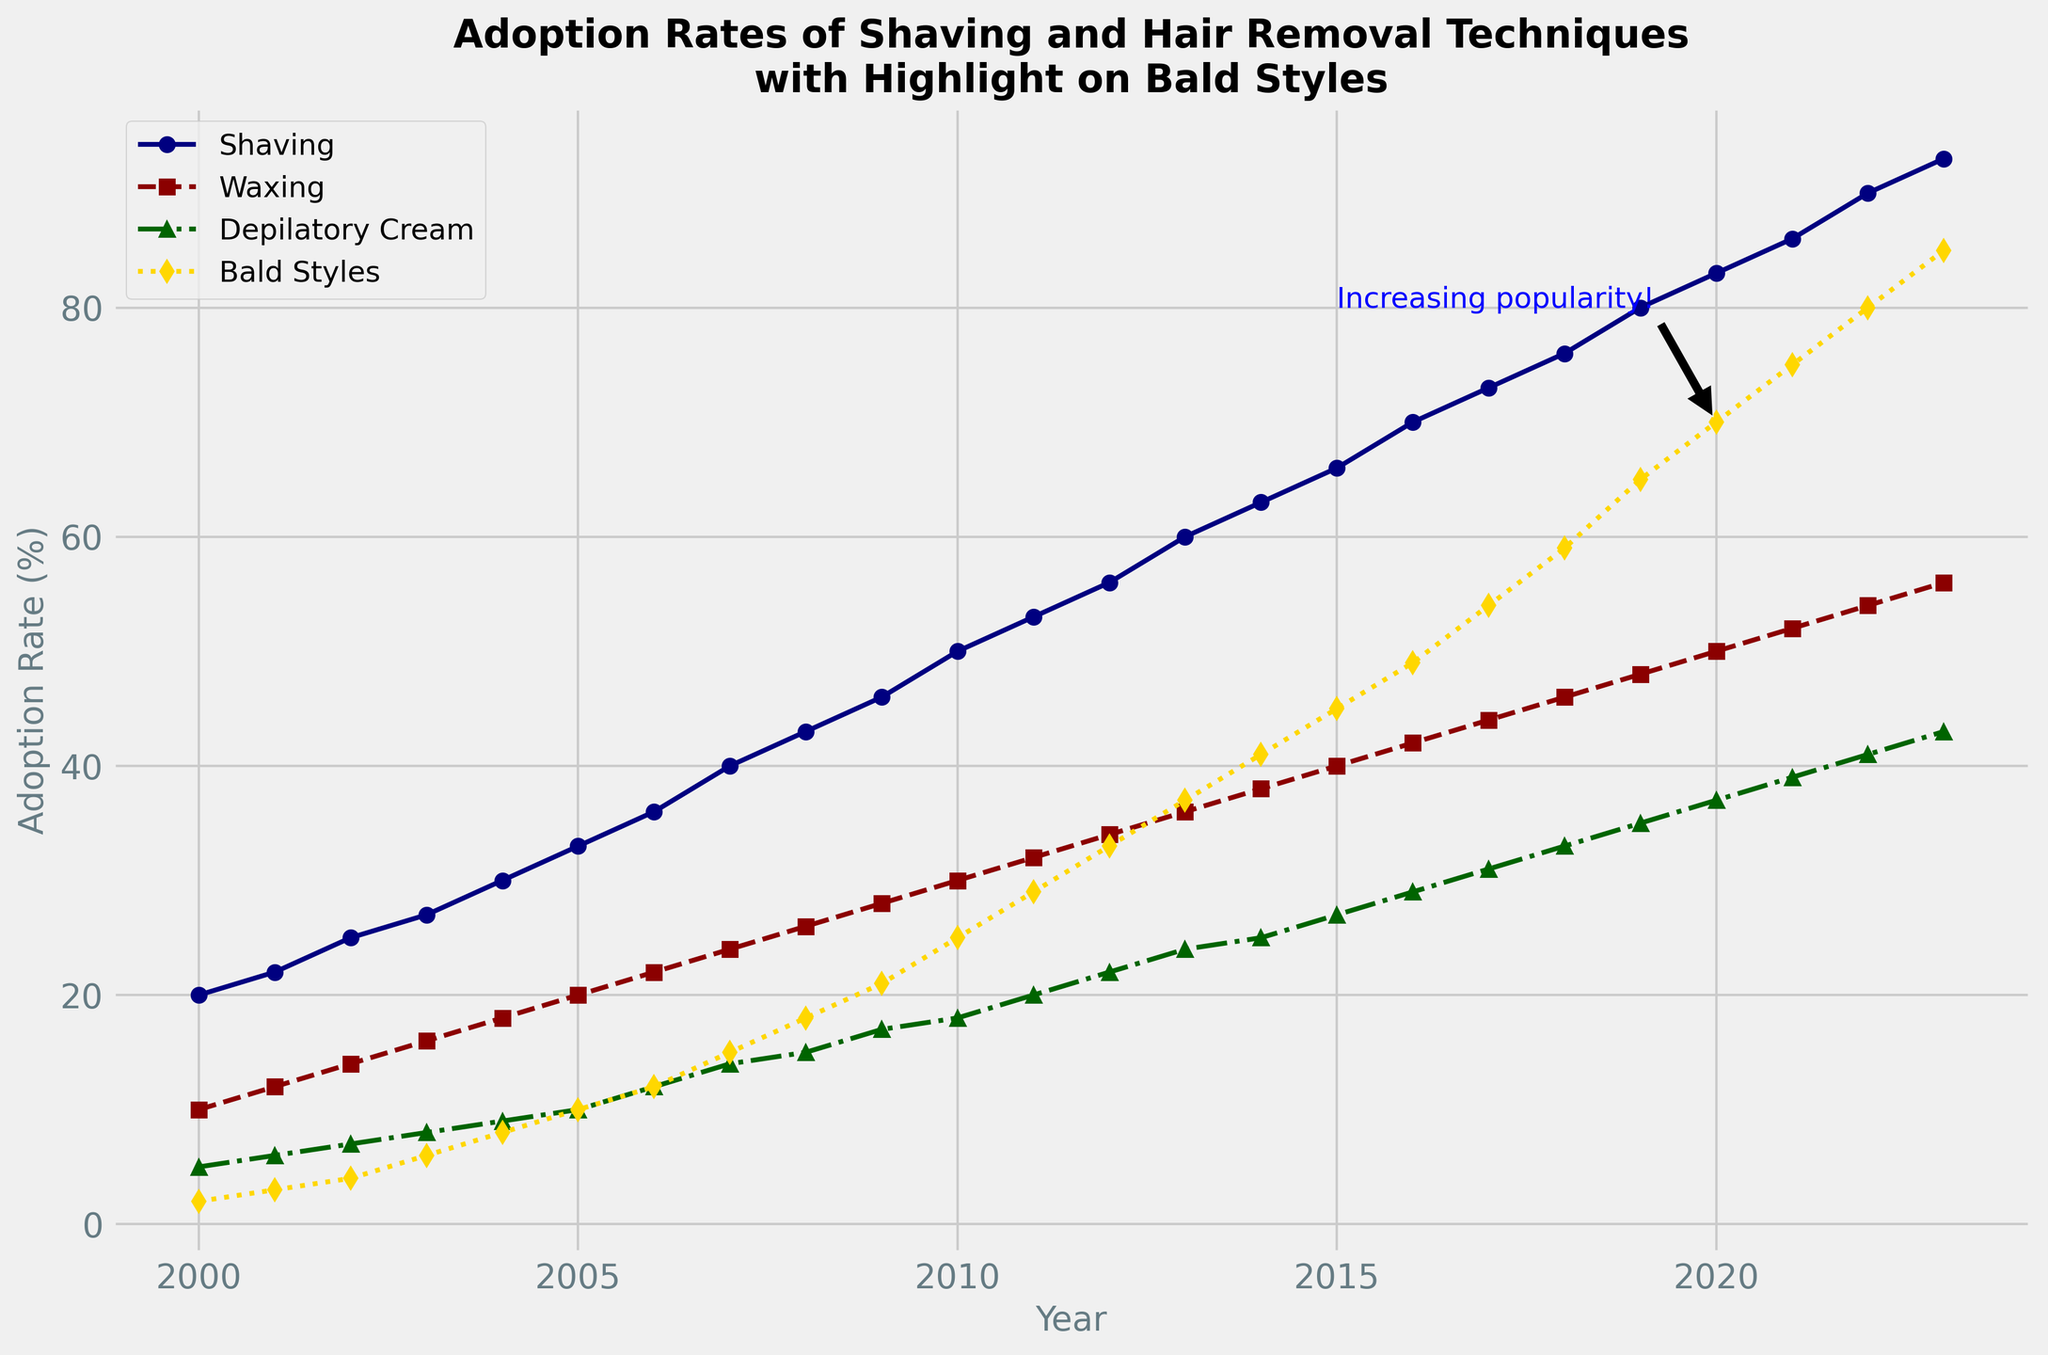Which hair removal technique had the highest adoption rate in 2023? By observing the line chart, the highest point in 2023 is associated with Shaving, as its value reaches 93%.
Answer: Shaving How did the adoption rate of Bald Styles change from 2000 to 2023? In 2000, the adoption rate of Bald Styles was 2%, and it increased to 85% in 2023. The difference is calculated as 85 - 2 = 83%.
Answer: Increased by 83% At which year did the adoption rate of Bald Styles reach 70%? The annotation on the figure "Increasing popularity!" is placed near the year 2020 with an adoption rate of 70%.
Answer: 2020 Which technique shows the steepest increase in adoption rate from 2000 to 2023? By comparing the slopes of the lines, Shaving shows the steepest increase, rising from 20% to 93%, a total increase of 73%.
Answer: Shaving What is the combined adoption rate of Shaving and Waxing in 2015? In 2015, the adoption rates are 66% for Shaving and 40% for Waxing. The combined rate is 66 + 40 = 106%.
Answer: 106% How does the adoption rate of Depilatory Cream in 2023 compare to that of Shaving in 2009? In 2023, the adoption rate for Depilatory Cream is 43%, while in 2009, the rate for Shaving is 46%. Thus, Shaving in 2009 had a higher rate.
Answer: Shaving in 2009 had a higher rate What is the average adoption rate of Bald Styles from 2000 to 2010? Sum the adoption rates of Bald Styles from 2000 to 2010 (2, 3, 4, 6, 8, 10, 12, 15, 18, 21, 25) = 124, then divide by the number of years (11). The average is 124 / 11 ≈ 11.27%.
Answer: Approximately 11.27% Which technique had the smallest increase in adoption rate between 2000 and 2023? Calculating the differences: Shaving increased by 73%, Waxing by 46%, Depilatory Cream by 38%, and Bald Styles by 83%. Depilatory Cream had the smallest increase.
Answer: Depilatory Cream What is the difference in adoption rates of Bald Styles and Depilatory Cream in 2010? In 2010, Bald Styles had an adoption rate of 25%, while Depilatory Cream had 18%. The difference is 25 - 18 = 7%.
Answer: 7% Which technique shows a consistent linear trend of increase throughout the years? By observing the lines, both Shaving and Bald Styles show relatively consistent linear increases without major deviations or dips.
Answer: Shaving and Bald Styles 